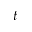Convert formula to latex. <formula><loc_0><loc_0><loc_500><loc_500>t</formula> 